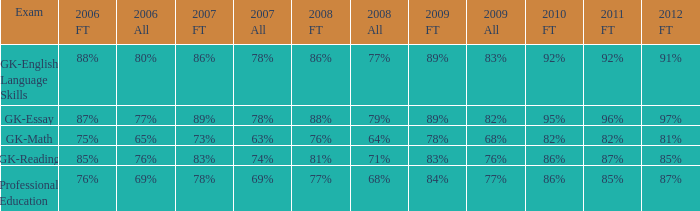What is the percentage for first time 2011 when the first time in 2009 is 68%? 82%. 